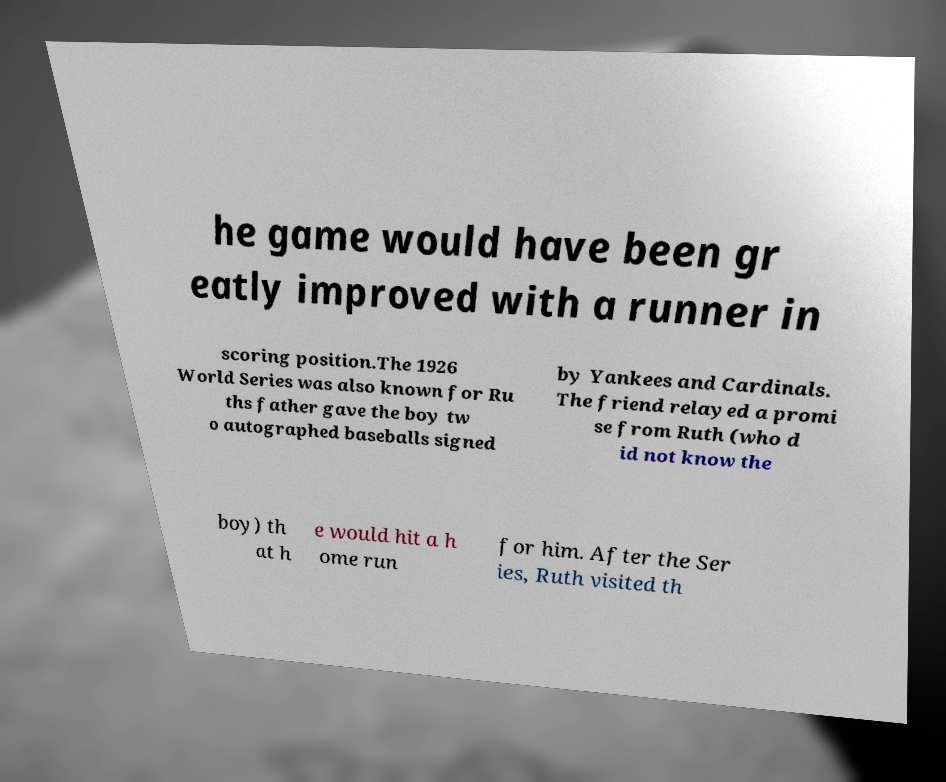Can you read and provide the text displayed in the image?This photo seems to have some interesting text. Can you extract and type it out for me? he game would have been gr eatly improved with a runner in scoring position.The 1926 World Series was also known for Ru ths father gave the boy tw o autographed baseballs signed by Yankees and Cardinals. The friend relayed a promi se from Ruth (who d id not know the boy) th at h e would hit a h ome run for him. After the Ser ies, Ruth visited th 